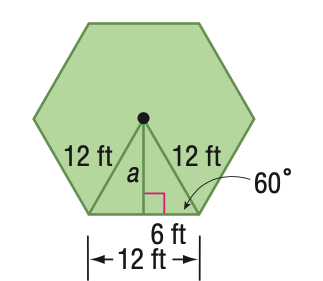Question: Find the area of a regular hexagon with a perimeter of 72 feet.
Choices:
A. 187.1
B. 305.5
C. 374.1
D. 532
Answer with the letter. Answer: C 